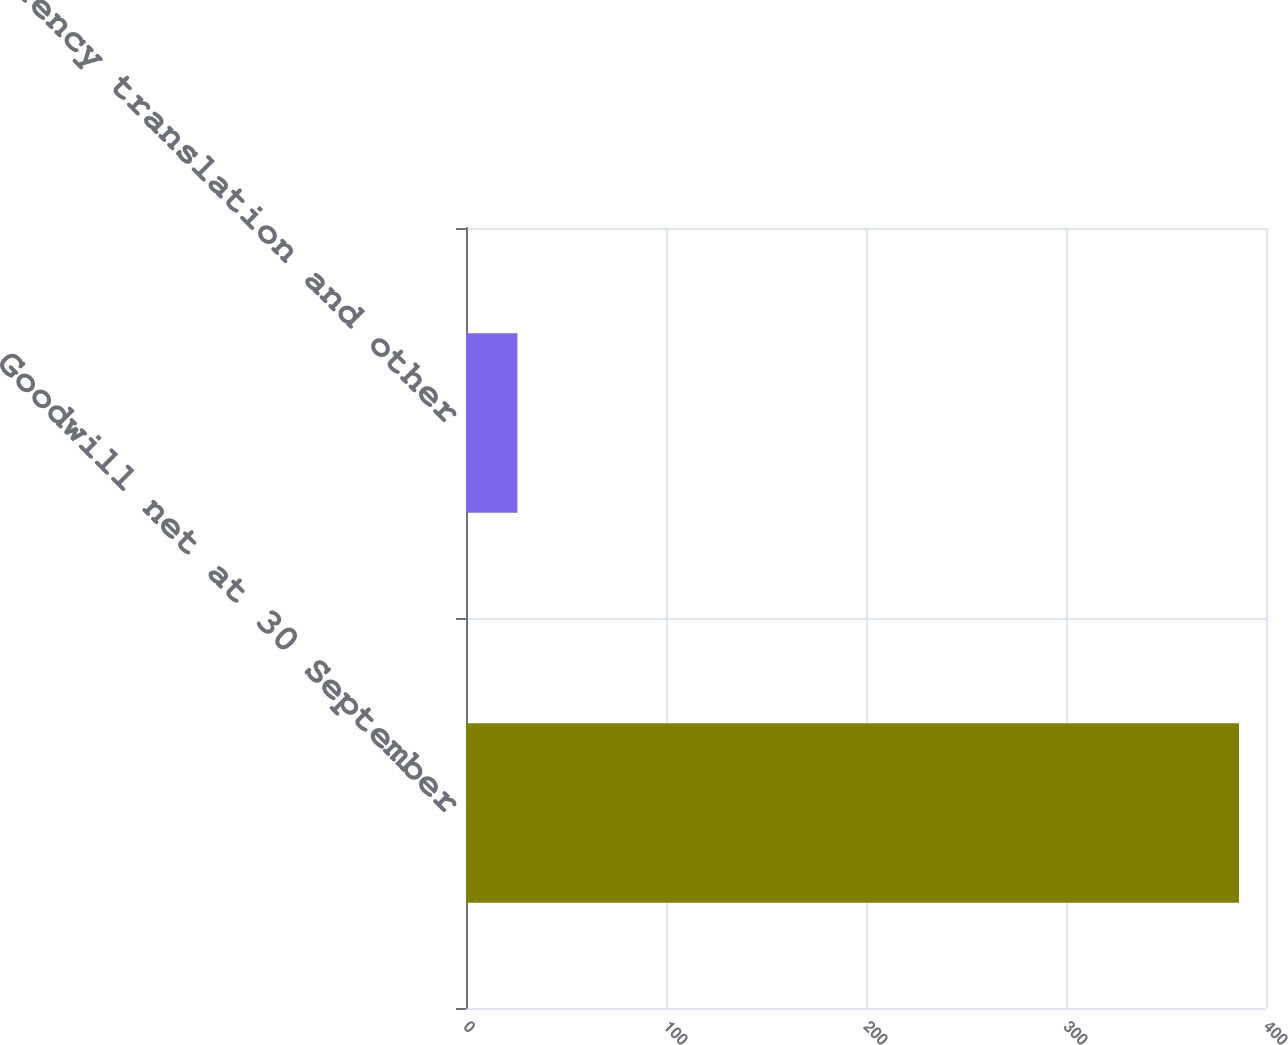<chart> <loc_0><loc_0><loc_500><loc_500><bar_chart><fcel>Goodwill net at 30 September<fcel>Currency translation and other<nl><fcel>386.5<fcel>25.7<nl></chart> 